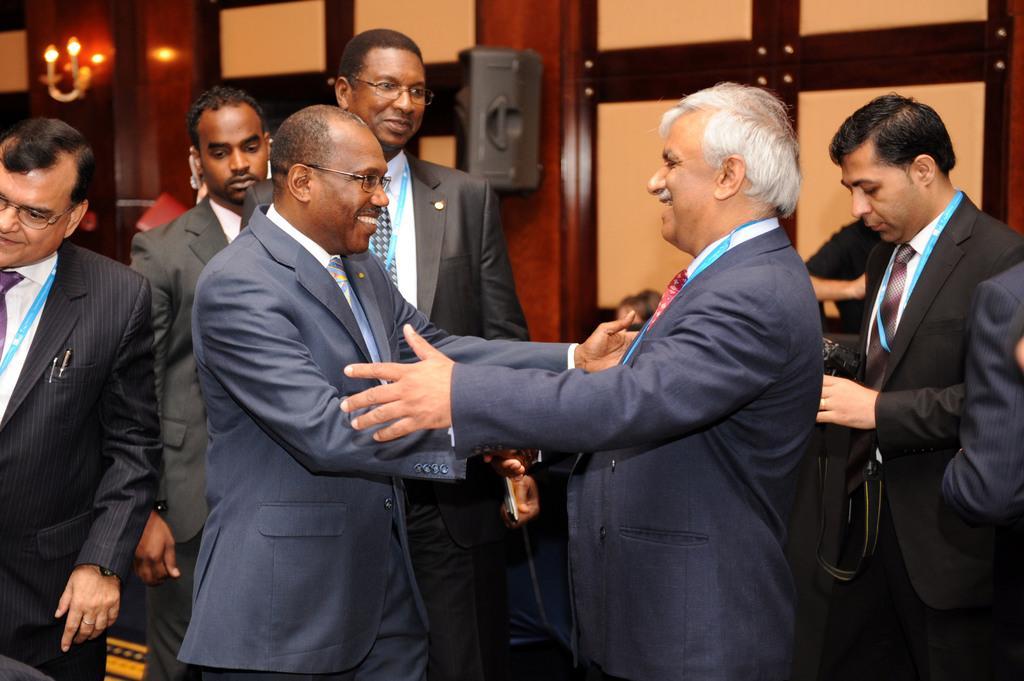Can you describe this image briefly? In this image there are two persons standing and smiling , and in the background there are group of people standing, a person holding a camera,speaker, light, wall. 